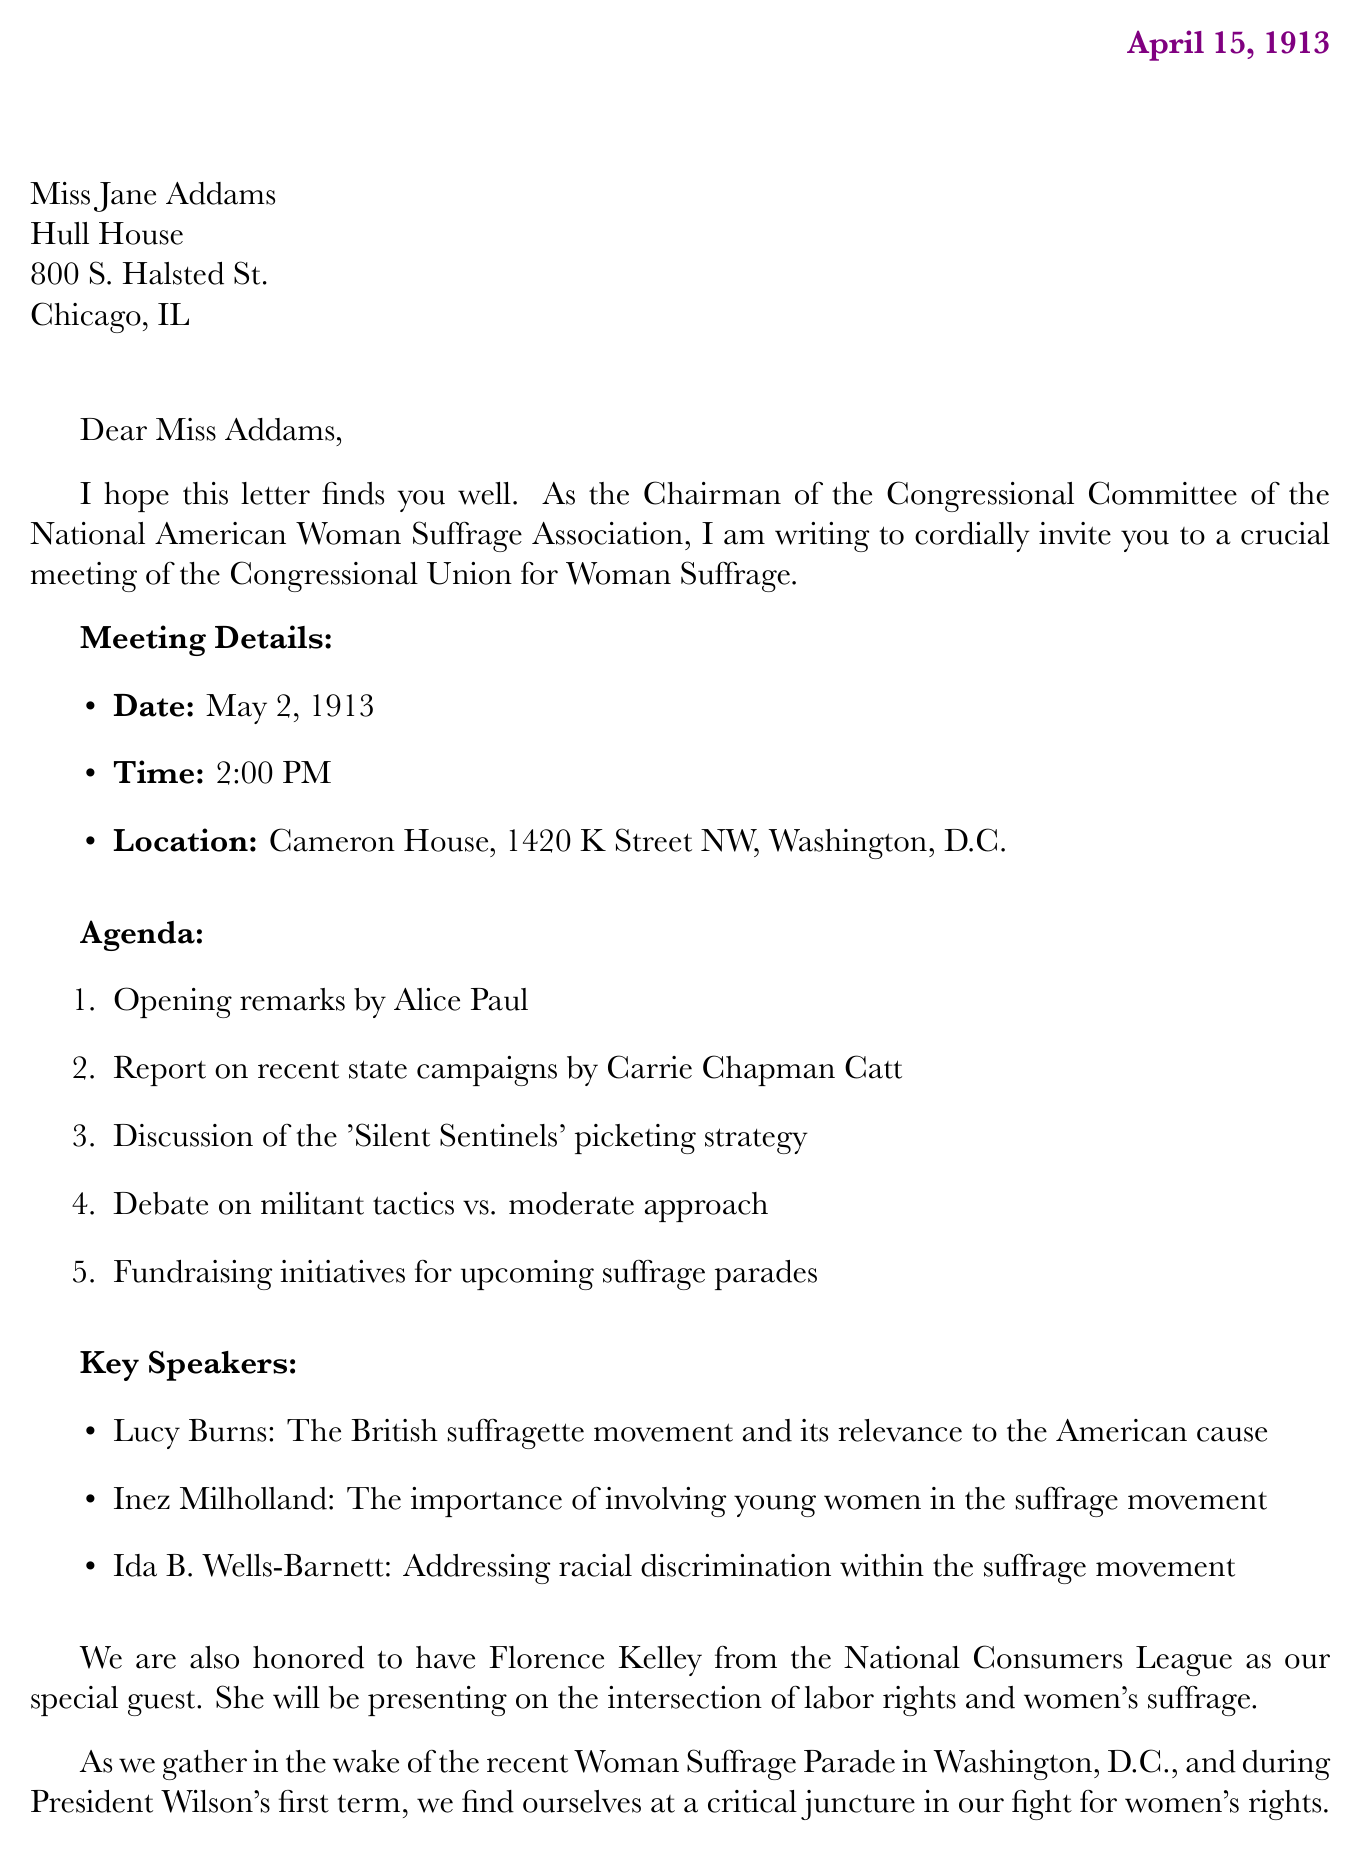what is the date of the meeting? The meeting date is explicitly mentioned in the document, which is May 2, 1913.
Answer: May 2, 1913 who is the sender of the letter? The sender's name and title are specified in the closing of the letter, identifying Alice Paul as the Chairman of the Congressional Committee of the National American Woman Suffrage Association.
Answer: Alice Paul where is the meeting located? The meeting location is clearly stated in the document as Cameron House, 1420 K Street NW, Washington, D.C.
Answer: Cameron House, 1420 K Street NW, Washington, D.C what is one topic discussed at the meeting? The agenda outlines several topics to be discussed, one of which is the 'Silent Sentinels' picketing strategy.
Answer: 'Silent Sentinels' picketing strategy who is the special guest mentioned in the letter? The document specifies Florence Kelley as a special guest along with her affiliation to the National Consumers League.
Answer: Florence Kelley what recent event is noted in the letter? The letter refers to the Woman Suffrage Parade of 1913 as a recent significant event in the context of the suffrage movement.
Answer: Woman Suffrage Parade of 1913 what is the purpose of the meeting? The primary purpose of the meeting is clearly stated as discussing strategy for the Congressional Union for Woman Suffrage.
Answer: To discuss strategy for the Congressional Union for Woman Suffrage which speaker is addressing racial discrimination in the suffrage movement? The document indicates that Ida B. Wells-Barnett will address racial discrimination within the suffrage movement during the meeting.
Answer: Ida B. Wells-Barnett what is the closing request of the letter? The closing remarks include a request for Jane Addams' presence and valuable input at the meeting, highlighting her influence in progressive circles.
Answer: Your presence and valuable input 